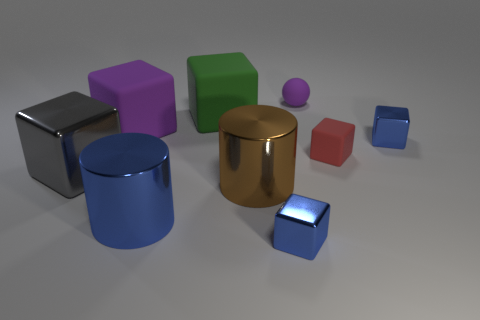How many matte objects are the same color as the tiny ball?
Ensure brevity in your answer.  1. What size is the rubber object that is the same color as the tiny rubber sphere?
Keep it short and to the point. Large. How many other things are the same size as the gray shiny thing?
Your response must be concise. 4. Does the large matte object to the right of the big blue shiny cylinder have the same color as the large shiny block?
Your response must be concise. No. Is the number of large purple matte cubes on the right side of the big blue metallic cylinder greater than the number of large green blocks?
Provide a succinct answer. No. Is there any other thing of the same color as the matte sphere?
Your answer should be compact. Yes. There is a tiny rubber thing that is behind the tiny blue block that is on the right side of the ball; what is its shape?
Provide a short and direct response. Sphere. Is the number of small things greater than the number of tiny cyan cubes?
Ensure brevity in your answer.  Yes. What number of big things are both to the left of the brown metal thing and right of the big purple block?
Your answer should be very brief. 2. What number of rubber blocks are in front of the red rubber thing that is in front of the tiny purple matte thing?
Offer a very short reply. 0. 